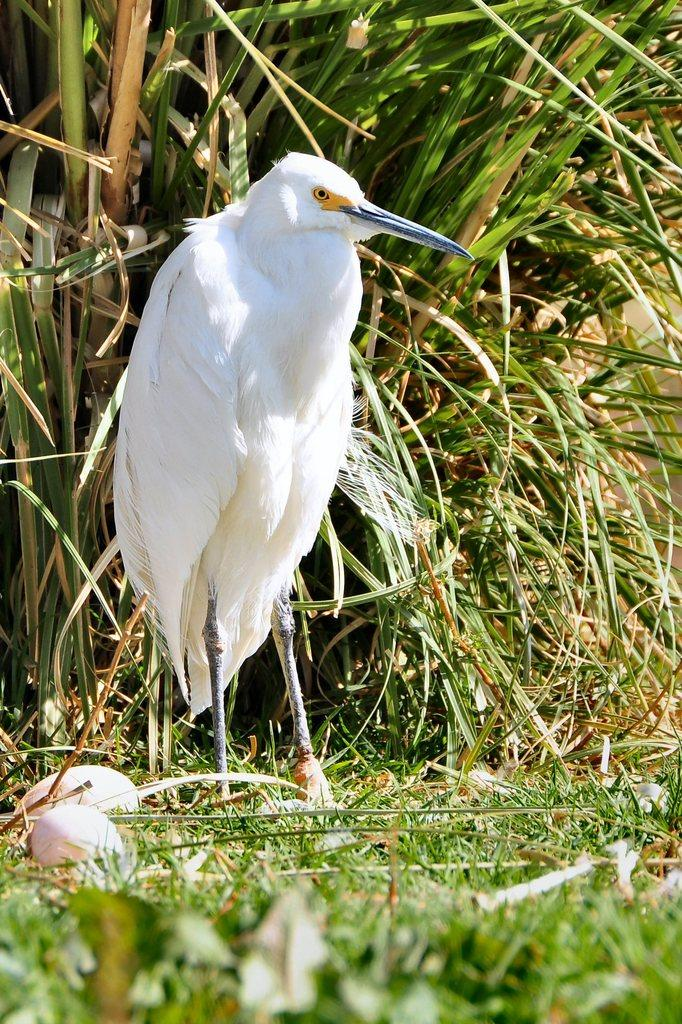What is the main subject in the middle of the image? There is a bird in the middle of the image. What can be seen at the bottom of the image? There are eggs and grass at the bottom of the image. What is located behind the bird? There is a plant behind the bird. Is there a bike visible in the image? No, there is no bike present in the image. Can you see a tree in the image? No, there is no tree visible in the image. 